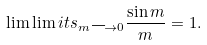Convert formula to latex. <formula><loc_0><loc_0><loc_500><loc_500>\lim \lim i t s _ { m \longrightarrow 0 } \frac { \sin m } { m } = 1 .</formula> 